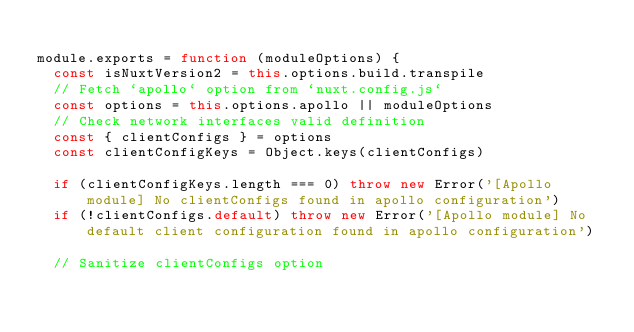Convert code to text. <code><loc_0><loc_0><loc_500><loc_500><_JavaScript_>
module.exports = function (moduleOptions) {
  const isNuxtVersion2 = this.options.build.transpile
  // Fetch `apollo` option from `nuxt.config.js`
  const options = this.options.apollo || moduleOptions
  // Check network interfaces valid definition
  const { clientConfigs } = options
  const clientConfigKeys = Object.keys(clientConfigs)

  if (clientConfigKeys.length === 0) throw new Error('[Apollo module] No clientConfigs found in apollo configuration')
  if (!clientConfigs.default) throw new Error('[Apollo module] No default client configuration found in apollo configuration')

  // Sanitize clientConfigs option</code> 